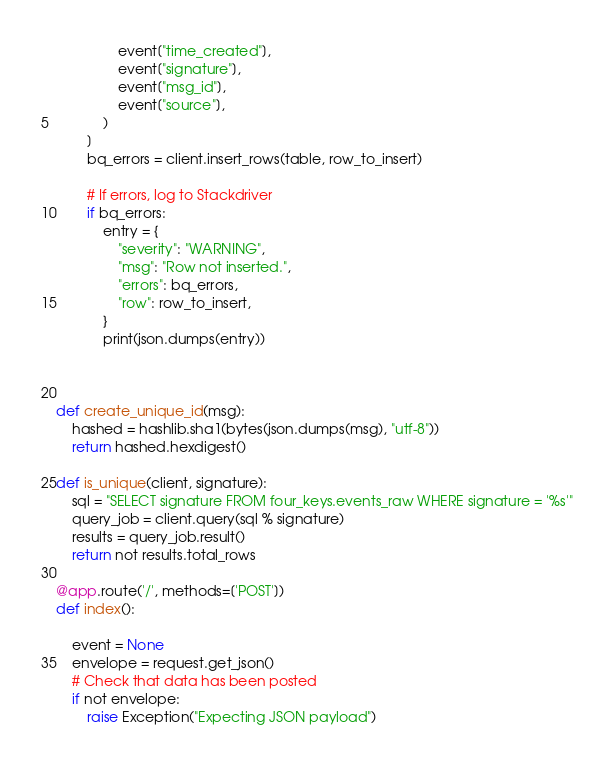<code> <loc_0><loc_0><loc_500><loc_500><_Python_>                event["time_created"],
                event["signature"],
                event["msg_id"],
                event["source"],
            )
        ]
        bq_errors = client.insert_rows(table, row_to_insert)

        # If errors, log to Stackdriver
        if bq_errors:
            entry = {
                "severity": "WARNING",
                "msg": "Row not inserted.",
                "errors": bq_errors,
                "row": row_to_insert,
            }
            print(json.dumps(entry))



def create_unique_id(msg):
    hashed = hashlib.sha1(bytes(json.dumps(msg), "utf-8"))
    return hashed.hexdigest()

def is_unique(client, signature):
    sql = "SELECT signature FROM four_keys.events_raw WHERE signature = '%s'"
    query_job = client.query(sql % signature)
    results = query_job.result()
    return not results.total_rows

@app.route('/', methods=['POST'])
def index():

    event = None
    envelope = request.get_json()
    # Check that data has been posted
    if not envelope:
        raise Exception("Expecting JSON payload")</code> 